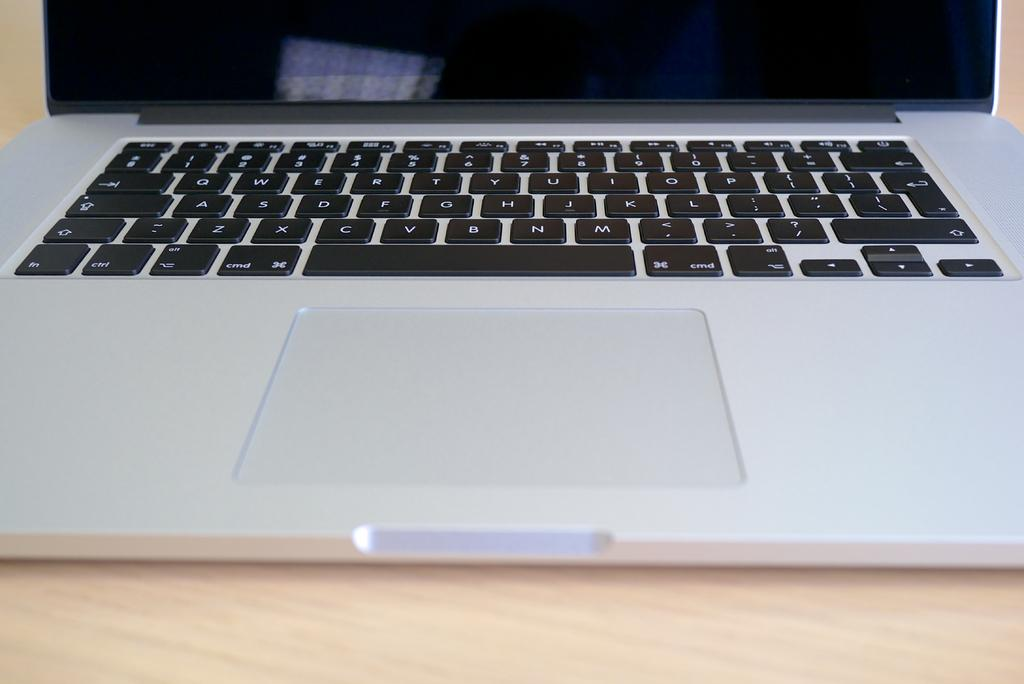<image>
Render a clear and concise summary of the photo. A laptop computer keyboard with letters Z, X, and C on the bottom row. 